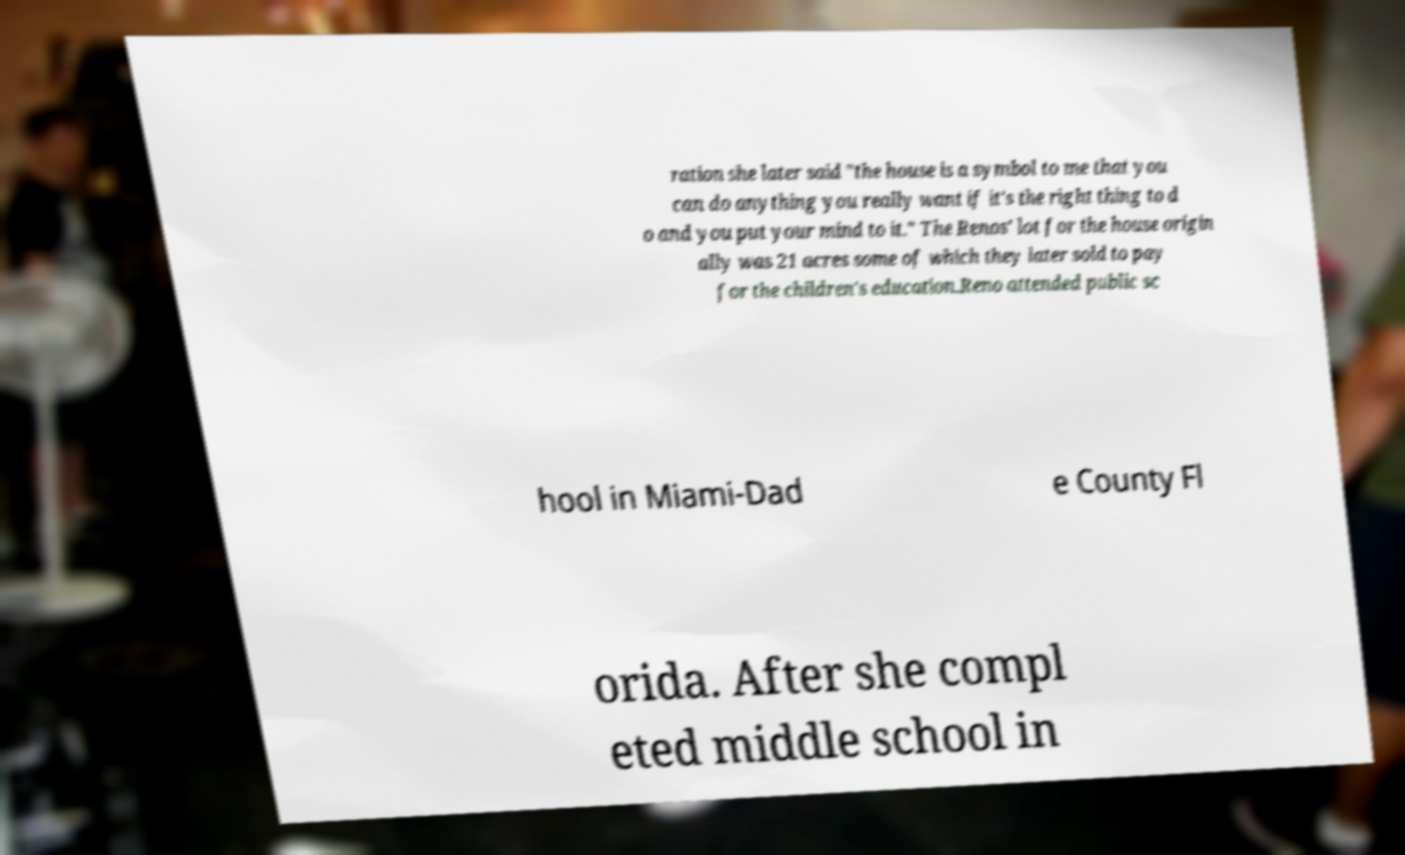What messages or text are displayed in this image? I need them in a readable, typed format. ration she later said "the house is a symbol to me that you can do anything you really want if it's the right thing to d o and you put your mind to it." The Renos' lot for the house origin ally was 21 acres some of which they later sold to pay for the children's education.Reno attended public sc hool in Miami-Dad e County Fl orida. After she compl eted middle school in 